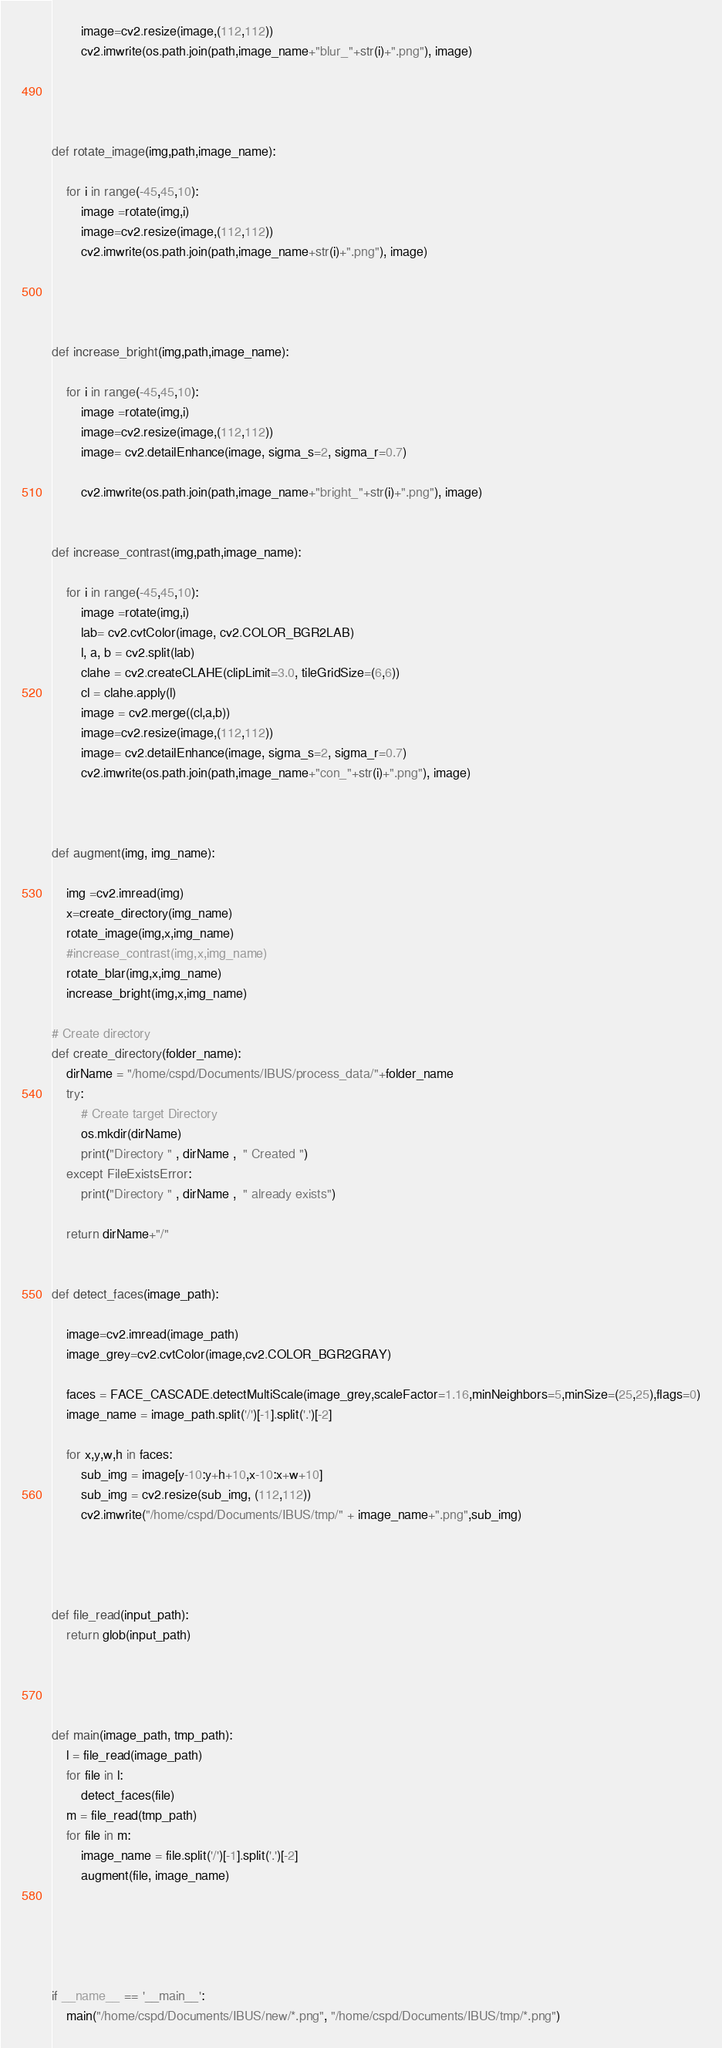Convert code to text. <code><loc_0><loc_0><loc_500><loc_500><_Python_>        image=cv2.resize(image,(112,112))
        cv2.imwrite(os.path.join(path,image_name+"blur_"+str(i)+".png"), image)




def rotate_image(img,path,image_name):
    
    for i in range(-45,45,10):
        image =rotate(img,i)
        image=cv2.resize(image,(112,112))
        cv2.imwrite(os.path.join(path,image_name+str(i)+".png"), image)




def increase_bright(img,path,image_name):
    
    for i in range(-45,45,10):
        image =rotate(img,i)
        image=cv2.resize(image,(112,112))
        image= cv2.detailEnhance(image, sigma_s=2, sigma_r=0.7)
        
        cv2.imwrite(os.path.join(path,image_name+"bright_"+str(i)+".png"), image)


def increase_contrast(img,path,image_name):
    
    for i in range(-45,45,10):
        image =rotate(img,i)
        lab= cv2.cvtColor(image, cv2.COLOR_BGR2LAB)
        l, a, b = cv2.split(lab)
        clahe = cv2.createCLAHE(clipLimit=3.0, tileGridSize=(6,6))
        cl = clahe.apply(l)
        image = cv2.merge((cl,a,b))
        image=cv2.resize(image,(112,112))
        image= cv2.detailEnhance(image, sigma_s=2, sigma_r=0.7)
        cv2.imwrite(os.path.join(path,image_name+"con_"+str(i)+".png"), image)



def augment(img, img_name):
    
    img =cv2.imread(img)
    x=create_directory(img_name)
    rotate_image(img,x,img_name)
    #increase_contrast(img,x,img_name)
    rotate_blar(img,x,img_name)
    increase_bright(img,x,img_name)
    
# Create directory
def create_directory(folder_name):
    dirName = "/home/cspd/Documents/IBUS/process_data/"+folder_name
    try:
        # Create target Directory
        os.mkdir(dirName)
        print("Directory " , dirName ,  " Created ") 
    except FileExistsError:
        print("Directory " , dirName ,  " already exists")

    return dirName+"/"


def detect_faces(image_path):
    
    image=cv2.imread(image_path)
    image_grey=cv2.cvtColor(image,cv2.COLOR_BGR2GRAY)

    faces = FACE_CASCADE.detectMultiScale(image_grey,scaleFactor=1.16,minNeighbors=5,minSize=(25,25),flags=0)
    image_name = image_path.split('/')[-1].split('.')[-2]

    for x,y,w,h in faces:
        sub_img = image[y-10:y+h+10,x-10:x+w+10]
        sub_img = cv2.resize(sub_img, (112,112))
        cv2.imwrite("/home/cspd/Documents/IBUS/tmp/" + image_name+".png",sub_img)




def file_read(input_path):
    return glob(input_path)




def main(image_path, tmp_path):
    l = file_read(image_path)
    for file in l:
        detect_faces(file)
    m = file_read(tmp_path)
    for file in m:
        image_name = file.split('/')[-1].split('.')[-2]
        augment(file, image_name)
        
        
        
        

if __name__ == '__main__':
    main("/home/cspd/Documents/IBUS/new/*.png", "/home/cspd/Documents/IBUS/tmp/*.png")





</code> 